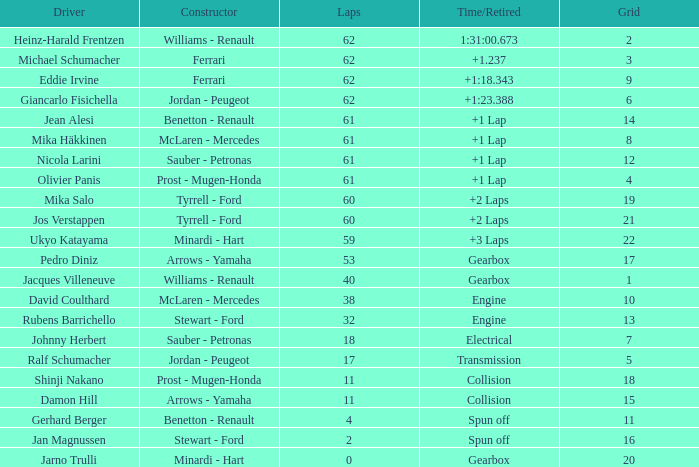What assembler has under 62 loops, a period/retired of gear mechanism, a grid more than 1, and pedro diniz steering? Arrows - Yamaha. 